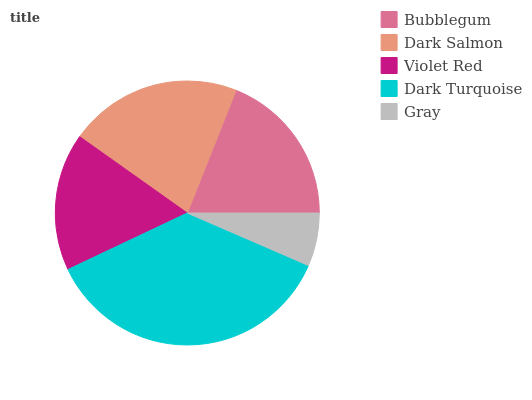Is Gray the minimum?
Answer yes or no. Yes. Is Dark Turquoise the maximum?
Answer yes or no. Yes. Is Dark Salmon the minimum?
Answer yes or no. No. Is Dark Salmon the maximum?
Answer yes or no. No. Is Dark Salmon greater than Bubblegum?
Answer yes or no. Yes. Is Bubblegum less than Dark Salmon?
Answer yes or no. Yes. Is Bubblegum greater than Dark Salmon?
Answer yes or no. No. Is Dark Salmon less than Bubblegum?
Answer yes or no. No. Is Bubblegum the high median?
Answer yes or no. Yes. Is Bubblegum the low median?
Answer yes or no. Yes. Is Dark Turquoise the high median?
Answer yes or no. No. Is Violet Red the low median?
Answer yes or no. No. 